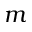Convert formula to latex. <formula><loc_0><loc_0><loc_500><loc_500>m</formula> 